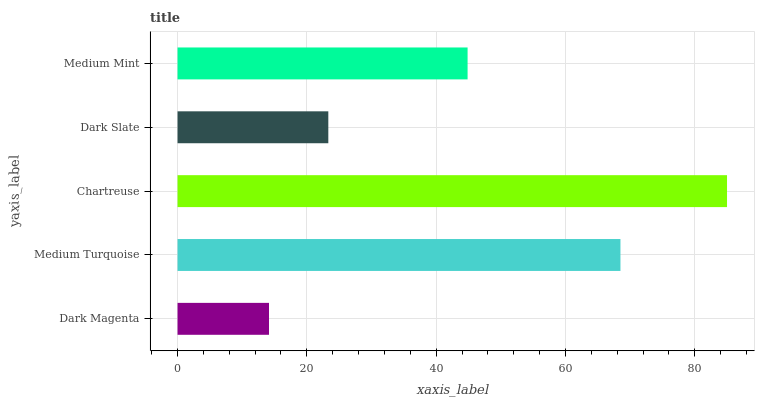Is Dark Magenta the minimum?
Answer yes or no. Yes. Is Chartreuse the maximum?
Answer yes or no. Yes. Is Medium Turquoise the minimum?
Answer yes or no. No. Is Medium Turquoise the maximum?
Answer yes or no. No. Is Medium Turquoise greater than Dark Magenta?
Answer yes or no. Yes. Is Dark Magenta less than Medium Turquoise?
Answer yes or no. Yes. Is Dark Magenta greater than Medium Turquoise?
Answer yes or no. No. Is Medium Turquoise less than Dark Magenta?
Answer yes or no. No. Is Medium Mint the high median?
Answer yes or no. Yes. Is Medium Mint the low median?
Answer yes or no. Yes. Is Dark Magenta the high median?
Answer yes or no. No. Is Dark Slate the low median?
Answer yes or no. No. 